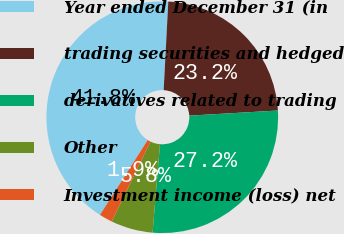<chart> <loc_0><loc_0><loc_500><loc_500><pie_chart><fcel>Year ended December 31 (in<fcel>trading securities and hedged<fcel>derivatives related to trading<fcel>Other<fcel>Investment income (loss) net<nl><fcel>41.8%<fcel>23.25%<fcel>27.25%<fcel>5.85%<fcel>1.85%<nl></chart> 